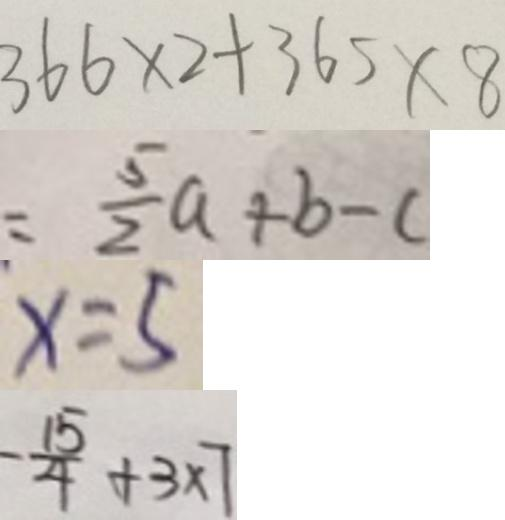Convert formula to latex. <formula><loc_0><loc_0><loc_500><loc_500>3 6 6 \times 2 + 3 6 5 \times 8 
 = \frac { 5 } { 2 } a + b - c 
 x = 5 
 - \frac { 1 5 } { 4 } + 3 \times 7</formula> 